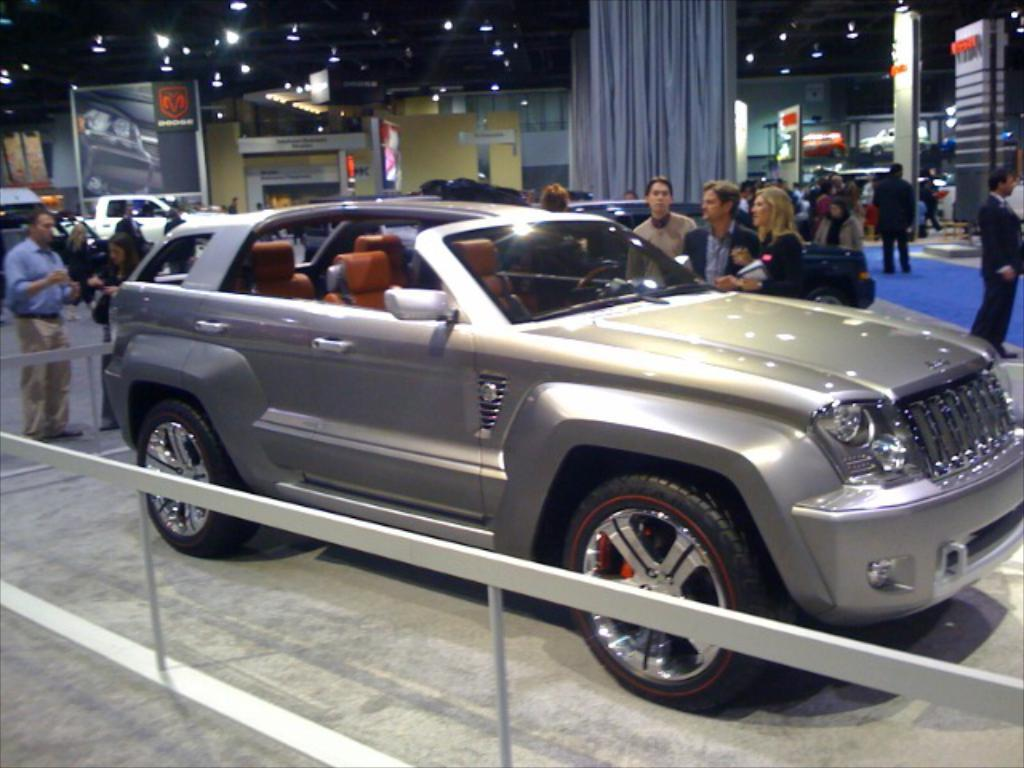What type of vehicles can be seen in the image? There are cars in the image. What are the people in the image doing? There is a group of people standing on a platform in the image. What can be seen in the background of the image? There are banners, lights, and curtains in the background of the image. What type of skirt is the pig wearing in the image? There are no pigs or skirts present in the image. What color is the coat worn by the person on the platform? The provided facts do not mention the color of any coats worn by the people on the platform. 